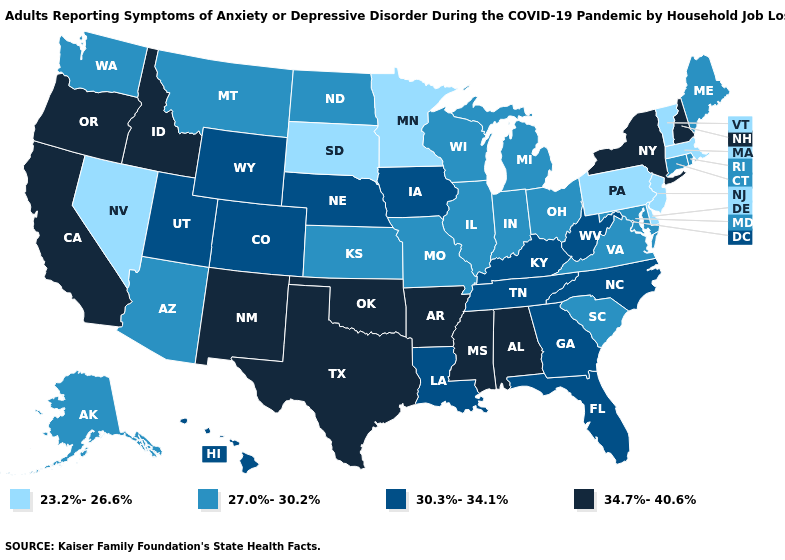Among the states that border Kansas , which have the lowest value?
Keep it brief. Missouri. Does the first symbol in the legend represent the smallest category?
Be succinct. Yes. Does South Dakota have the highest value in the USA?
Write a very short answer. No. Does Nevada have the same value as Rhode Island?
Quick response, please. No. What is the lowest value in the MidWest?
Quick response, please. 23.2%-26.6%. What is the value of Arizona?
Short answer required. 27.0%-30.2%. What is the lowest value in the USA?
Answer briefly. 23.2%-26.6%. What is the value of Nevada?
Short answer required. 23.2%-26.6%. Does Wyoming have the same value as Colorado?
Short answer required. Yes. Among the states that border Idaho , which have the lowest value?
Keep it brief. Nevada. What is the lowest value in the West?
Answer briefly. 23.2%-26.6%. Does the map have missing data?
Short answer required. No. What is the value of Pennsylvania?
Quick response, please. 23.2%-26.6%. Which states have the highest value in the USA?
Concise answer only. Alabama, Arkansas, California, Idaho, Mississippi, New Hampshire, New Mexico, New York, Oklahoma, Oregon, Texas. What is the value of Delaware?
Answer briefly. 23.2%-26.6%. 